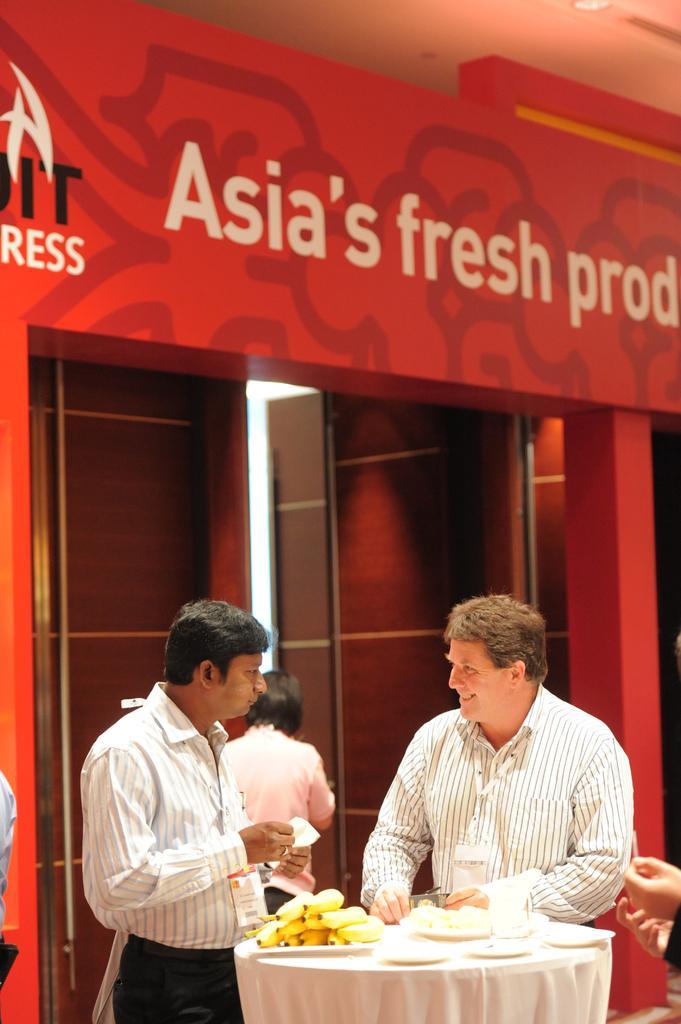Could you give a brief overview of what you see in this image? In this image we can see a few people, there is a table, on that we can see bananas, plates, and a glass, there is the text on the wall, also we can see the light, and the door. 